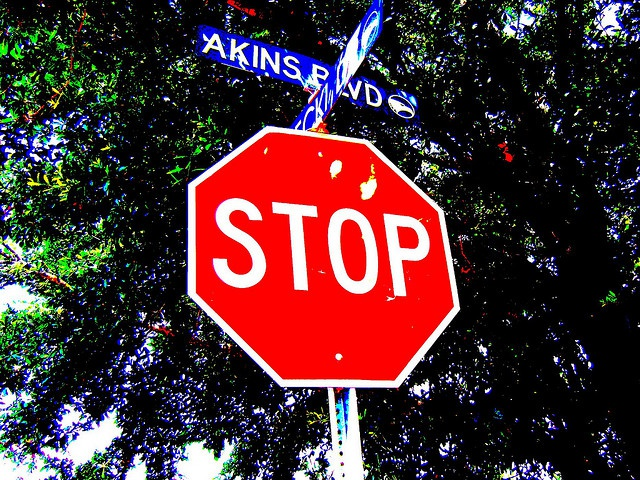Describe the objects in this image and their specific colors. I can see a stop sign in darkgreen, red, white, lightpink, and salmon tones in this image. 